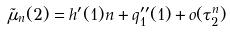<formula> <loc_0><loc_0><loc_500><loc_500>\tilde { \mu } _ { n } ( 2 ) = h ^ { \prime } ( 1 ) n + q ^ { \prime \prime } _ { 1 } ( 1 ) + o ( \tau ^ { n } _ { 2 } )</formula> 